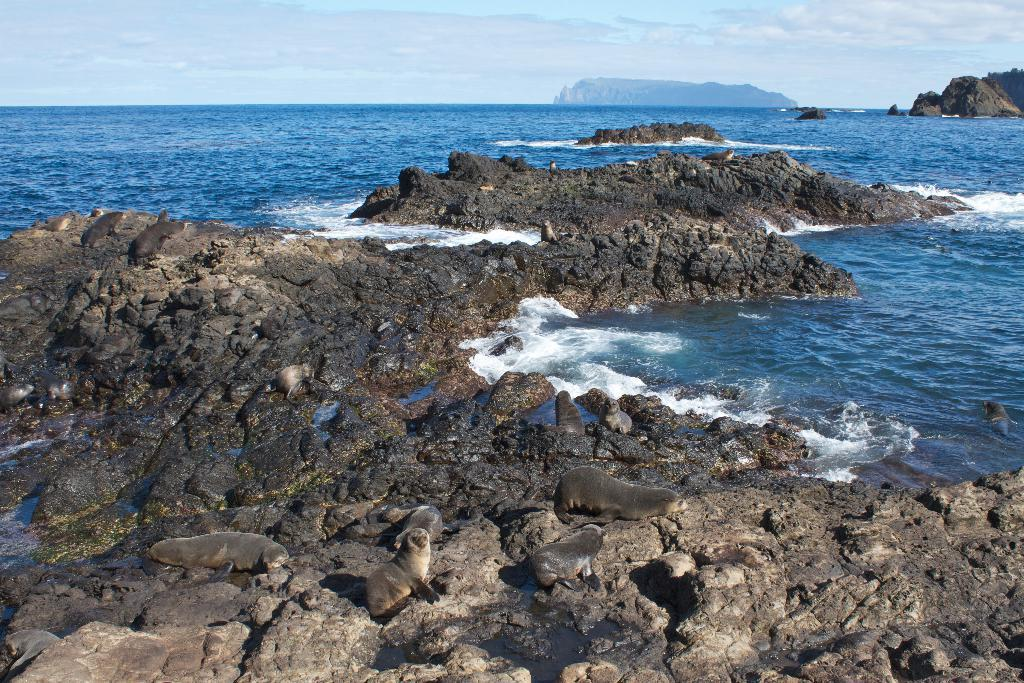What animals can be seen in the image? There are seals on the rocks in the image. Where are the seals located? The seals are on the rocks near the water of the ocean. What can be seen in the background of the image? There are rocks and a mountain in the background of the image. What is the color of the sky in the image? The sky in the image is blue, with clouds visible. Can you tell me where the umbrella is placed in the image? There is no umbrella present in the image. What type of receipt can be seen in the hands of the seals? There are no receipts present in the image, as seals do not handle such items. 